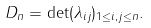<formula> <loc_0><loc_0><loc_500><loc_500>D _ { n } = \det ( \lambda _ { i j } ) _ { 1 \leq i , j \leq n } .</formula> 